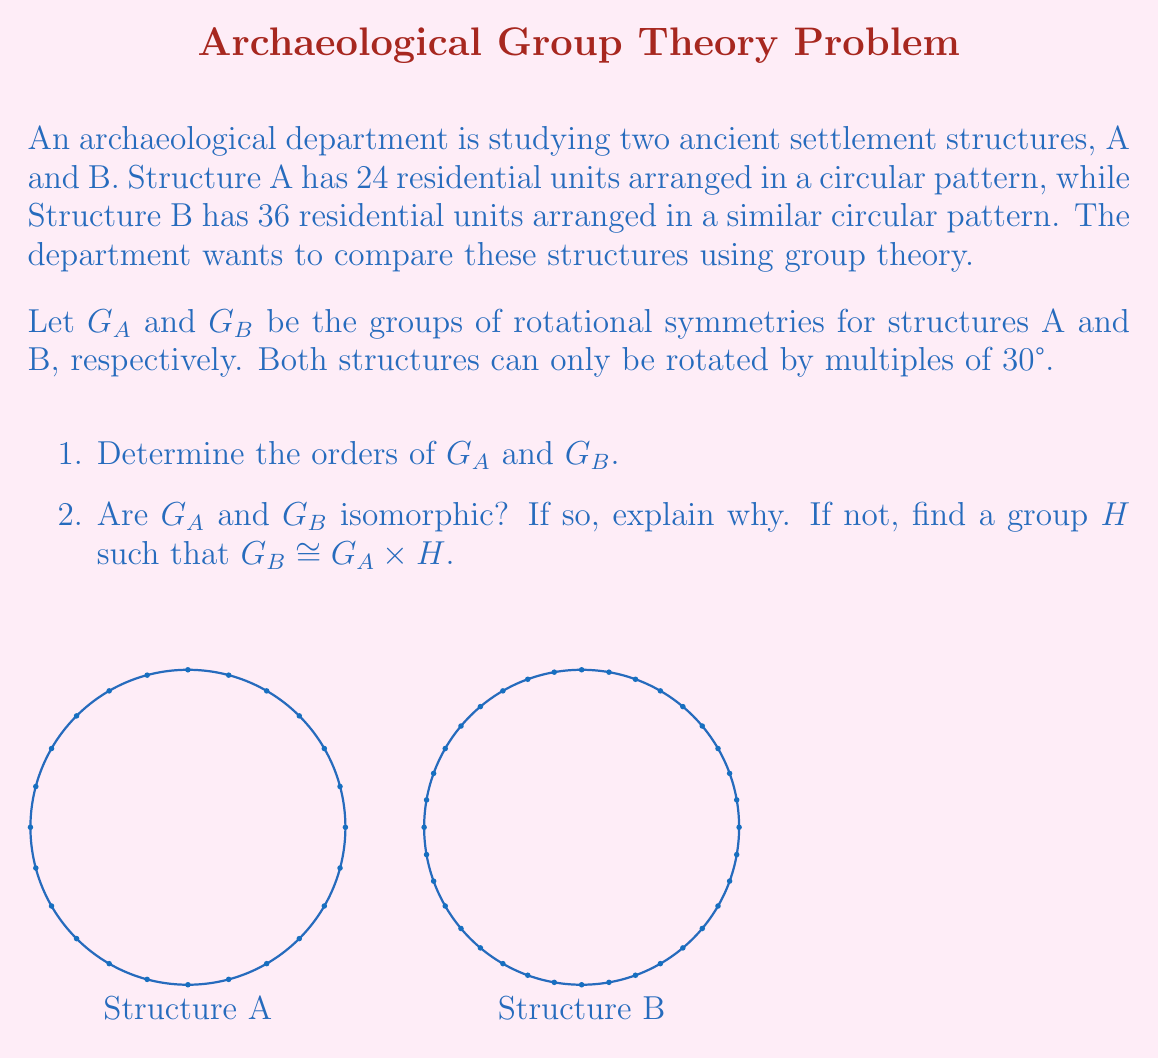What is the answer to this math problem? Let's approach this step-by-step:

1. Determining the orders of $G_A$ and $G_B$:
   - For Structure A: A full rotation is 360°, and the smallest rotation is 30°.
     $|G_A| = 360° \div 30° = 12$
   - For Structure B: Similarly, $|G_B| = 360° \div 30° = 12$

2. Isomorphism between $G_A$ and $G_B$:
   - Both $G_A$ and $G_B$ are cyclic groups of order 12.
   - By the fundamental theorem of cyclic groups, any two cyclic groups of the same order are isomorphic.
   - Therefore, $G_A \cong G_B$

3. Finding $H$ such that $G_B \cong G_A \times H$:
   - Since $G_A$ and $G_B$ are already isomorphic, we can choose $H$ to be the trivial group $\{e\}$.
   - This satisfies the isomorphism because $G_A \times \{e\} \cong G_A \cong G_B$

4. Explanation using isomorphism theorems:
   - The First Isomorphism Theorem states that if $\phi: G \to G'$ is a surjective homomorphism, then $G/\text{ker}(\phi) \cong \text{im}(\phi)$.
   - In this case, we can define a surjective homomorphism $\phi: G_B \to G_A$ that maps rotations in $G_B$ to corresponding rotations in $G_A$.
   - The kernel of this homomorphism is trivial, as each element in $G_B$ maps to a unique element in $G_A$.
   - Therefore, $G_B/\{e\} \cong G_A$, which implies $G_B \cong G_A$.

This analysis shows that despite the different number of residential units, the rotational symmetry groups of both structures are essentially the same, indicating a fundamental similarity in their circular arrangements.
Answer: $G_A \cong G_B \cong C_{12}$, $H = \{e\}$ 